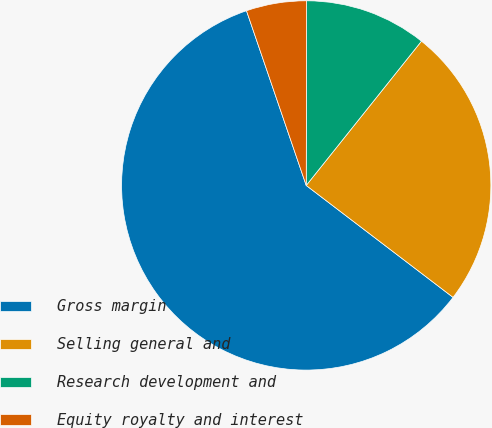<chart> <loc_0><loc_0><loc_500><loc_500><pie_chart><fcel>Gross margin<fcel>Selling general and<fcel>Research development and<fcel>Equity royalty and interest<nl><fcel>59.39%<fcel>24.64%<fcel>10.69%<fcel>5.28%<nl></chart> 